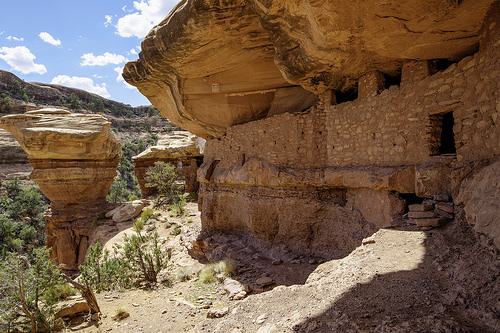<image>
Is there a rock behind the sky? No. The rock is not behind the sky. From this viewpoint, the rock appears to be positioned elsewhere in the scene. 